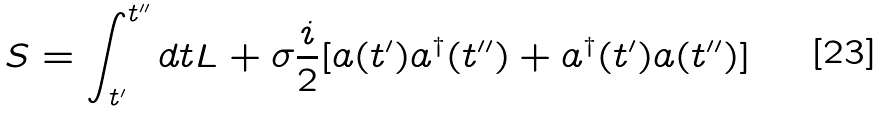<formula> <loc_0><loc_0><loc_500><loc_500>S = \int _ { t ^ { \prime } } ^ { t ^ { \prime \prime } } d t L + \sigma \frac { i } { 2 } [ a ( t ^ { \prime } ) a ^ { \dagger } ( t ^ { \prime \prime } ) + a ^ { \dagger } ( t ^ { \prime } ) a ( t ^ { \prime \prime } ) ]</formula> 